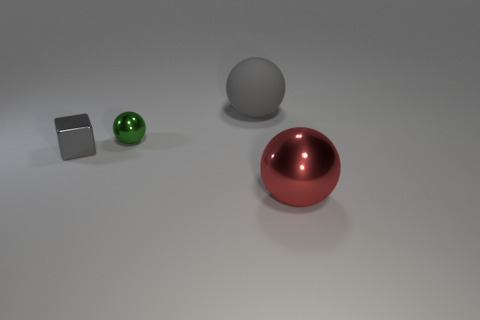Subtract all tiny metallic balls. How many balls are left? 2 Subtract all red spheres. How many spheres are left? 2 Subtract 2 balls. How many balls are left? 1 Subtract all yellow cubes. How many brown balls are left? 0 Subtract all tiny green metal balls. Subtract all tiny green balls. How many objects are left? 2 Add 1 tiny gray cubes. How many tiny gray cubes are left? 2 Add 4 yellow matte cubes. How many yellow matte cubes exist? 4 Add 3 gray things. How many objects exist? 7 Subtract 0 green cylinders. How many objects are left? 4 Subtract all balls. How many objects are left? 1 